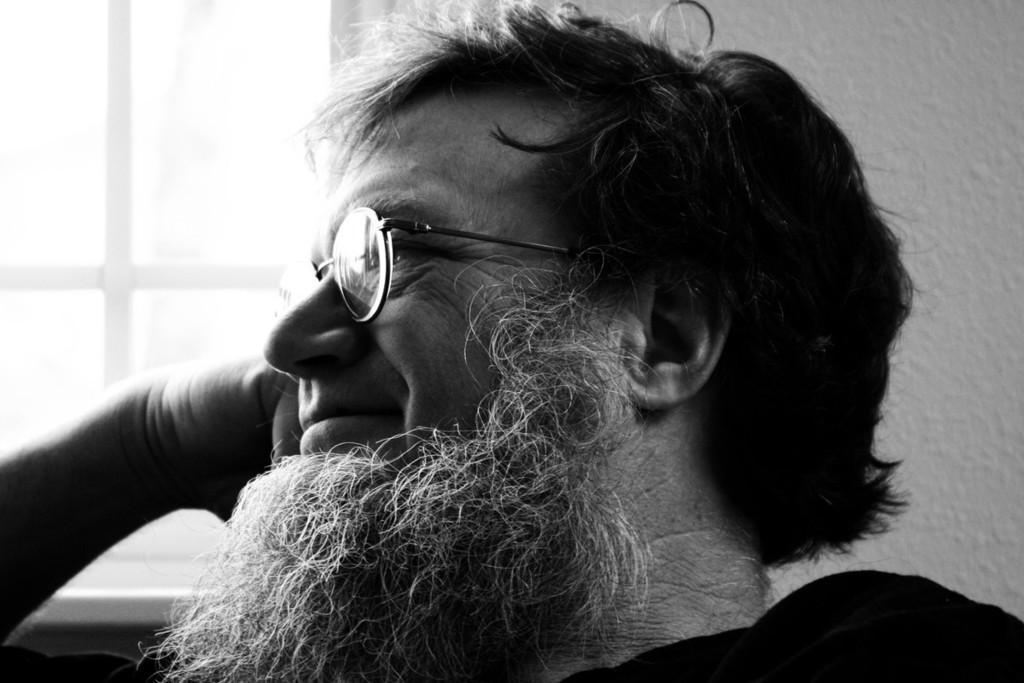Could you give a brief overview of what you see in this image? This is a black and white image. In this image we can see a man. On the backside we can see a wall and a window. 